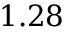Convert formula to latex. <formula><loc_0><loc_0><loc_500><loc_500>1 . 2 8</formula> 